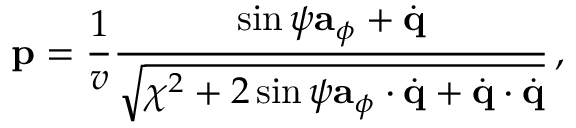Convert formula to latex. <formula><loc_0><loc_0><loc_500><loc_500>{ p } = \frac { 1 } { v } \frac { \sin \psi { a } _ { \phi } + \dot { q } } { \sqrt { \chi ^ { 2 } + 2 \sin \psi { a } _ { \phi } \cdot \dot { q } + \dot { q } \cdot \dot { q } } } \, ,</formula> 